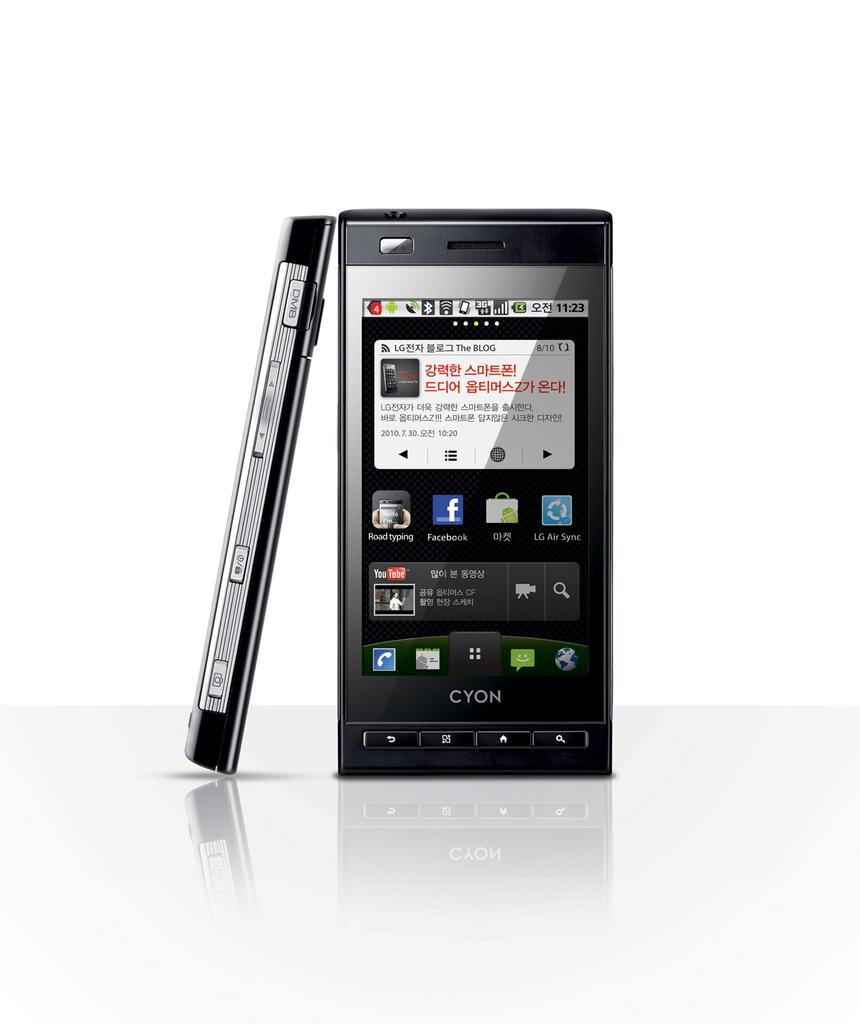<image>
Relay a brief, clear account of the picture shown. A cell phone that says Cyon is on a white background. 